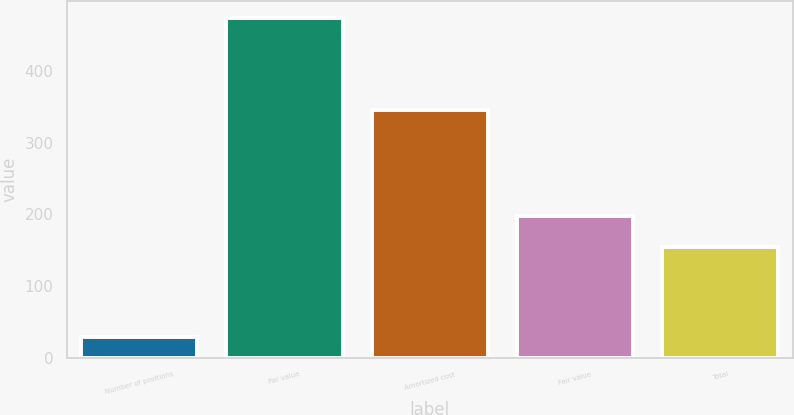Convert chart to OTSL. <chart><loc_0><loc_0><loc_500><loc_500><bar_chart><fcel>Number of positions<fcel>Par value<fcel>Amortized cost<fcel>Fair value<fcel>Total<nl><fcel>29<fcel>473<fcel>345<fcel>198.4<fcel>154<nl></chart> 